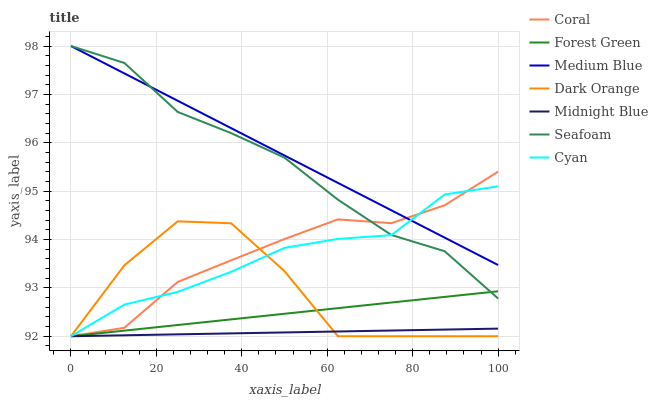Does Midnight Blue have the minimum area under the curve?
Answer yes or no. Yes. Does Medium Blue have the maximum area under the curve?
Answer yes or no. Yes. Does Coral have the minimum area under the curve?
Answer yes or no. No. Does Coral have the maximum area under the curve?
Answer yes or no. No. Is Medium Blue the smoothest?
Answer yes or no. Yes. Is Dark Orange the roughest?
Answer yes or no. Yes. Is Midnight Blue the smoothest?
Answer yes or no. No. Is Midnight Blue the roughest?
Answer yes or no. No. Does Dark Orange have the lowest value?
Answer yes or no. Yes. Does Medium Blue have the lowest value?
Answer yes or no. No. Does Seafoam have the highest value?
Answer yes or no. Yes. Does Coral have the highest value?
Answer yes or no. No. Is Forest Green less than Medium Blue?
Answer yes or no. Yes. Is Seafoam greater than Dark Orange?
Answer yes or no. Yes. Does Midnight Blue intersect Coral?
Answer yes or no. Yes. Is Midnight Blue less than Coral?
Answer yes or no. No. Is Midnight Blue greater than Coral?
Answer yes or no. No. Does Forest Green intersect Medium Blue?
Answer yes or no. No. 